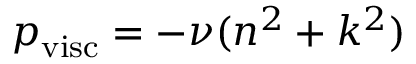<formula> <loc_0><loc_0><loc_500><loc_500>p _ { v i s c } = - \nu ( n ^ { 2 } + k ^ { 2 } )</formula> 